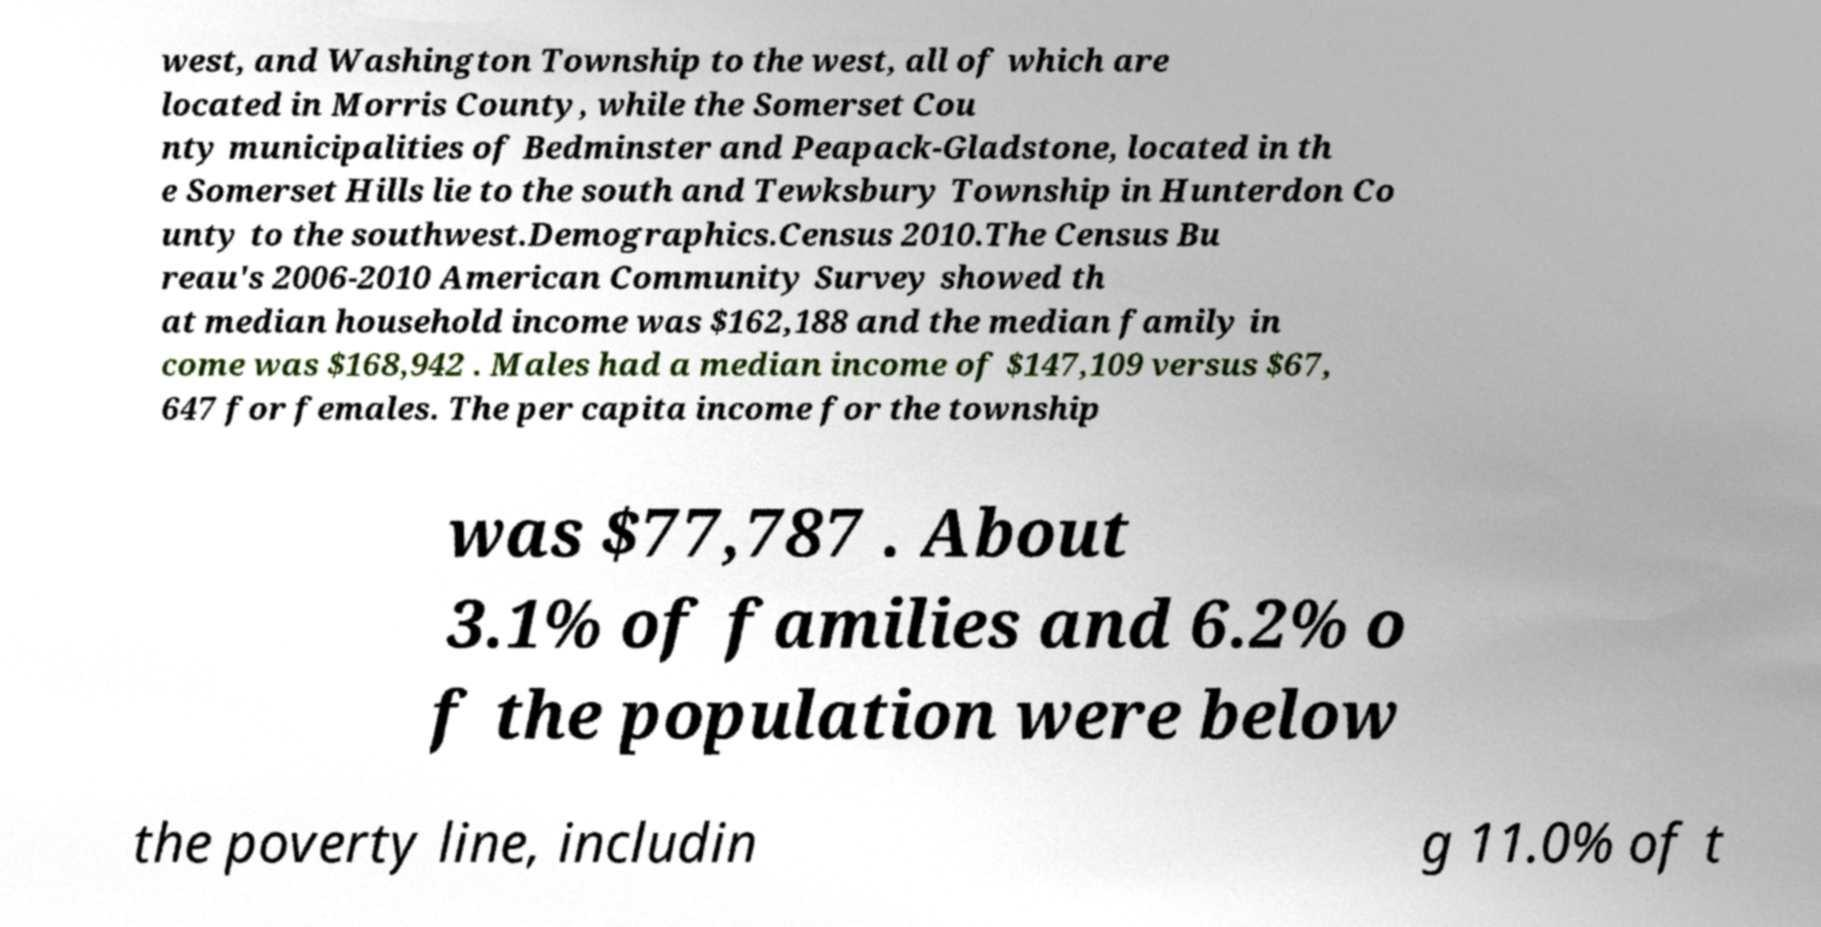I need the written content from this picture converted into text. Can you do that? west, and Washington Township to the west, all of which are located in Morris County, while the Somerset Cou nty municipalities of Bedminster and Peapack-Gladstone, located in th e Somerset Hills lie to the south and Tewksbury Township in Hunterdon Co unty to the southwest.Demographics.Census 2010.The Census Bu reau's 2006-2010 American Community Survey showed th at median household income was $162,188 and the median family in come was $168,942 . Males had a median income of $147,109 versus $67, 647 for females. The per capita income for the township was $77,787 . About 3.1% of families and 6.2% o f the population were below the poverty line, includin g 11.0% of t 